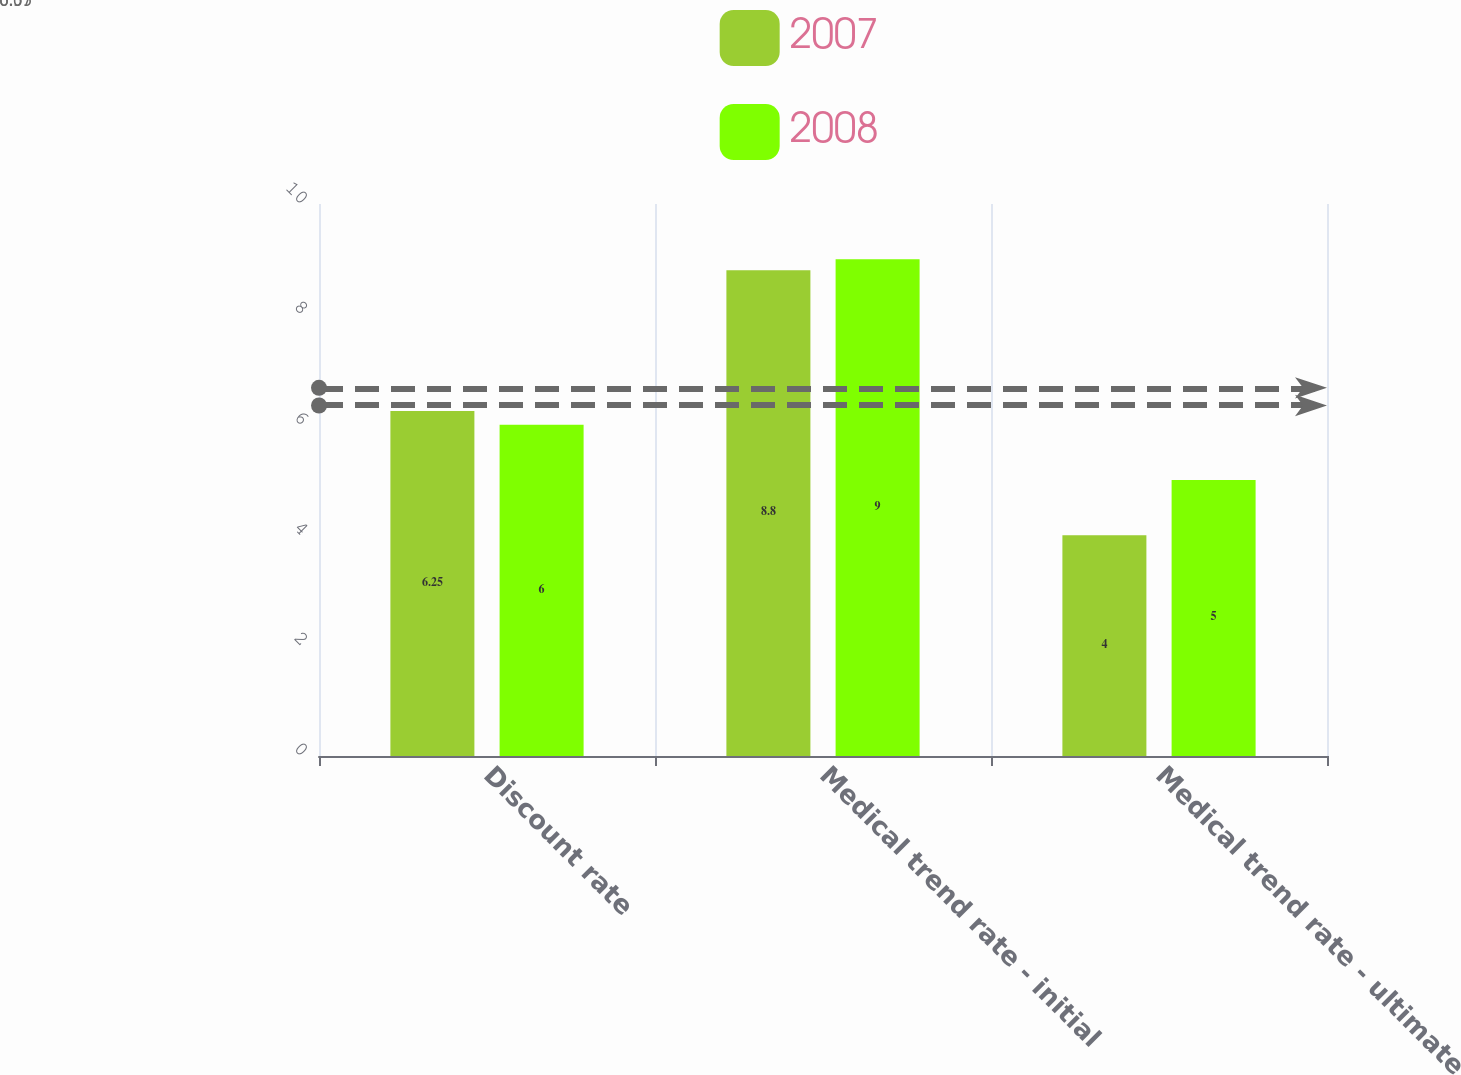Convert chart. <chart><loc_0><loc_0><loc_500><loc_500><stacked_bar_chart><ecel><fcel>Discount rate<fcel>Medical trend rate - initial<fcel>Medical trend rate - ultimate<nl><fcel>2007<fcel>6.25<fcel>8.8<fcel>4<nl><fcel>2008<fcel>6<fcel>9<fcel>5<nl></chart> 